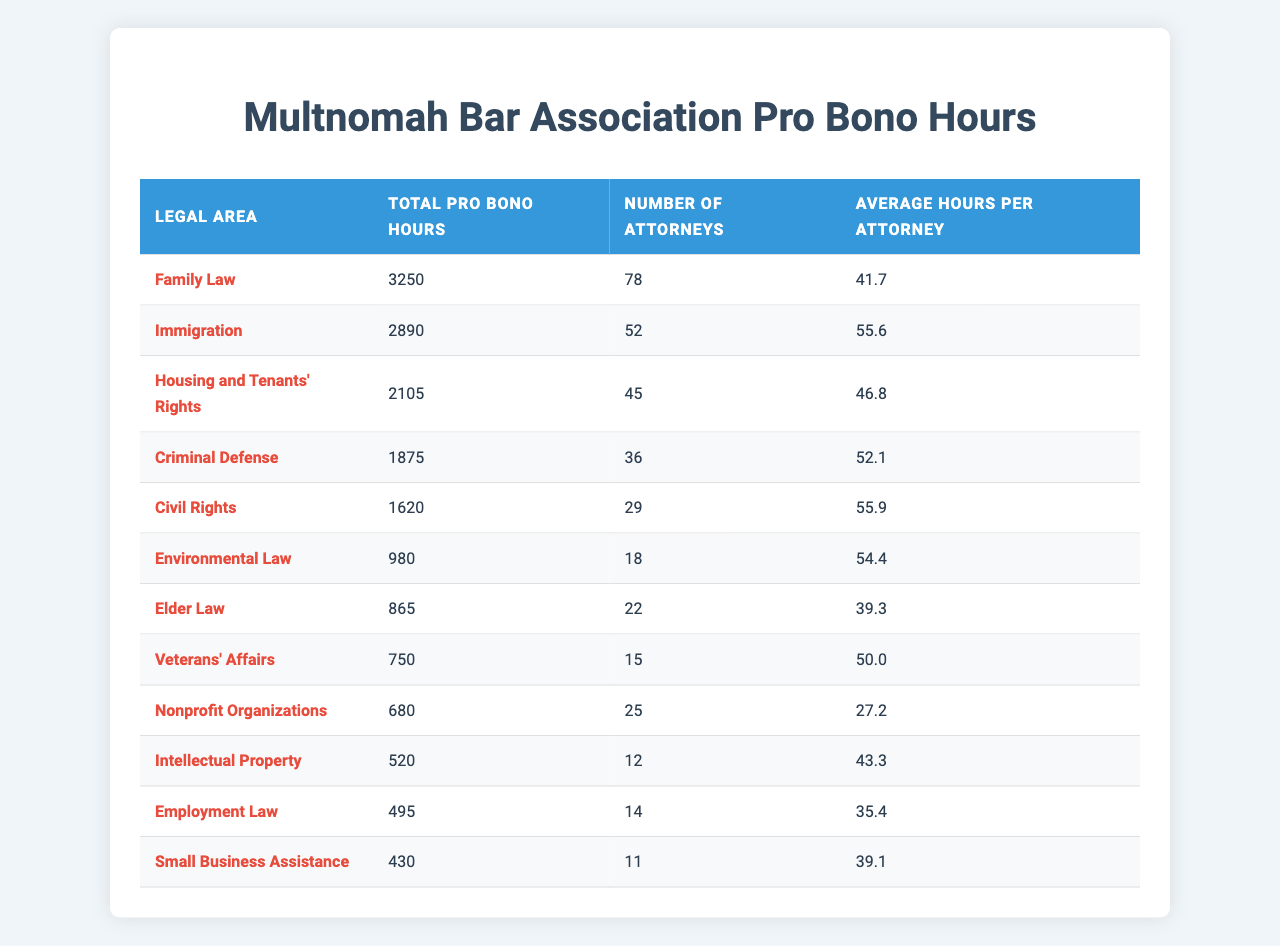What is the total number of pro bono hours contributed by MBA members in Family Law? The table lists Family Law with a total of 3,250 pro bono hours.
Answer: 3,250 How many attorneys contributed to pro bono efforts in Immigration? The table states that 52 attorneys contributed to Immigration-related pro bono work.
Answer: 52 Which legal area had the highest average pro bono hours per attorney? The Immigration area has an average of 55.6 hours, which is the highest of all listed areas.
Answer: Immigration What is the average number of pro bono hours contributed by attorneys in Employment Law? The table indicates that attorneys in Employment Law contributed an average of 35.4 hours each.
Answer: 35.4 Which legal area had the lowest total pro bono hours? According to the table, Small Business Assistance had the lowest total at 430 hours.
Answer: Small Business Assistance What is the combined total of pro bono hours for Environmental Law and Elder Law? The total for Environmental Law is 980 hours, and for Elder Law, it's 865 hours. When combined: 980 + 865 = 1,845 hours.
Answer: 1,845 Is the average pro bono hours per attorney in Housing and Tenants' Rights higher than that in Elder Law? The average for Housing and Tenants' Rights is 46.8 hours, while Elder Law is 39.3 hours. Therefore, Housing and Tenants’ Rights has a higher average.
Answer: Yes What is the difference in total pro bono hours between Criminal Defense and Civil Rights? Criminal Defense has 1,875 hours and Civil Rights has 1,620 hours. The difference is 1,875 - 1,620 = 255 hours.
Answer: 255 If the numbers of attorneys in Family Law and Civil Rights were combined, what would be the average pro bono hours per attorney? Family Law has 78 attorneys with 3,250 hours and Civil Rights has 29 attorneys with 1,620 hours. Combined hours: 3,250 + 1,620 = 4,870 and combined attorneys: 78 + 29 = 107. Average: 4,870 / 107 ≈ 45.5 hours.
Answer: 45.5 What proportion of total pro bono hours contributed by MBA members is attributed to Veterans’ Affairs? Total pro bono hours across all areas is 14,325 (sum of all hours). Veterans’ Affairs contributed 750 hours, so the proportion is 750 / 14,325 ≈ 0.052 or 5.2%.
Answer: 5.2% 